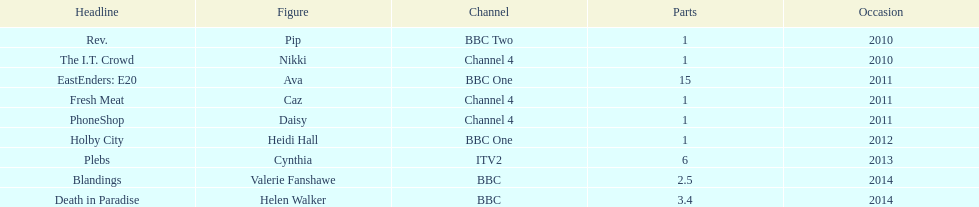How many titles have at least 5 episodes? 2. 